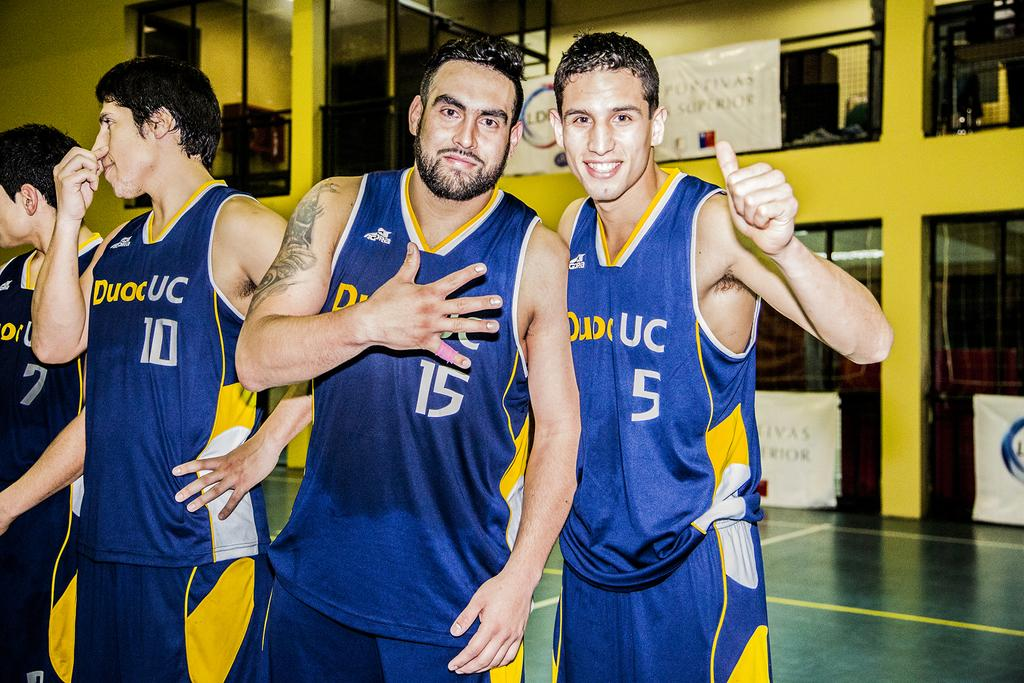Provide a one-sentence caption for the provided image. Four UC basketball team with 2 players giving gratitude. 